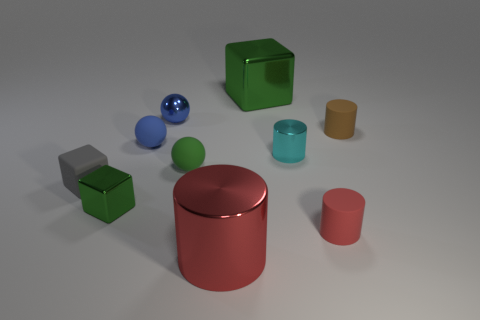Does the cyan object have the same material as the big red cylinder?
Offer a terse response. Yes. There is a gray block that is the same size as the cyan thing; what is it made of?
Offer a very short reply. Rubber. What number of objects are red things that are behind the big red metal cylinder or brown things?
Keep it short and to the point. 2. Are there an equal number of small cyan metallic cylinders that are behind the large green cube and cyan spheres?
Your answer should be compact. Yes. Do the tiny shiny cylinder and the large shiny cylinder have the same color?
Your answer should be compact. No. There is a small thing that is in front of the gray rubber thing and on the left side of the cyan shiny thing; what color is it?
Your response must be concise. Green. What number of spheres are either large brown rubber things or large green metal objects?
Provide a short and direct response. 0. Is the number of cyan metallic objects on the left side of the tiny green sphere less than the number of big green metal things?
Offer a very short reply. Yes. What is the shape of the brown thing that is the same material as the tiny green ball?
Provide a succinct answer. Cylinder. What number of other small spheres have the same color as the small shiny ball?
Ensure brevity in your answer.  1. 